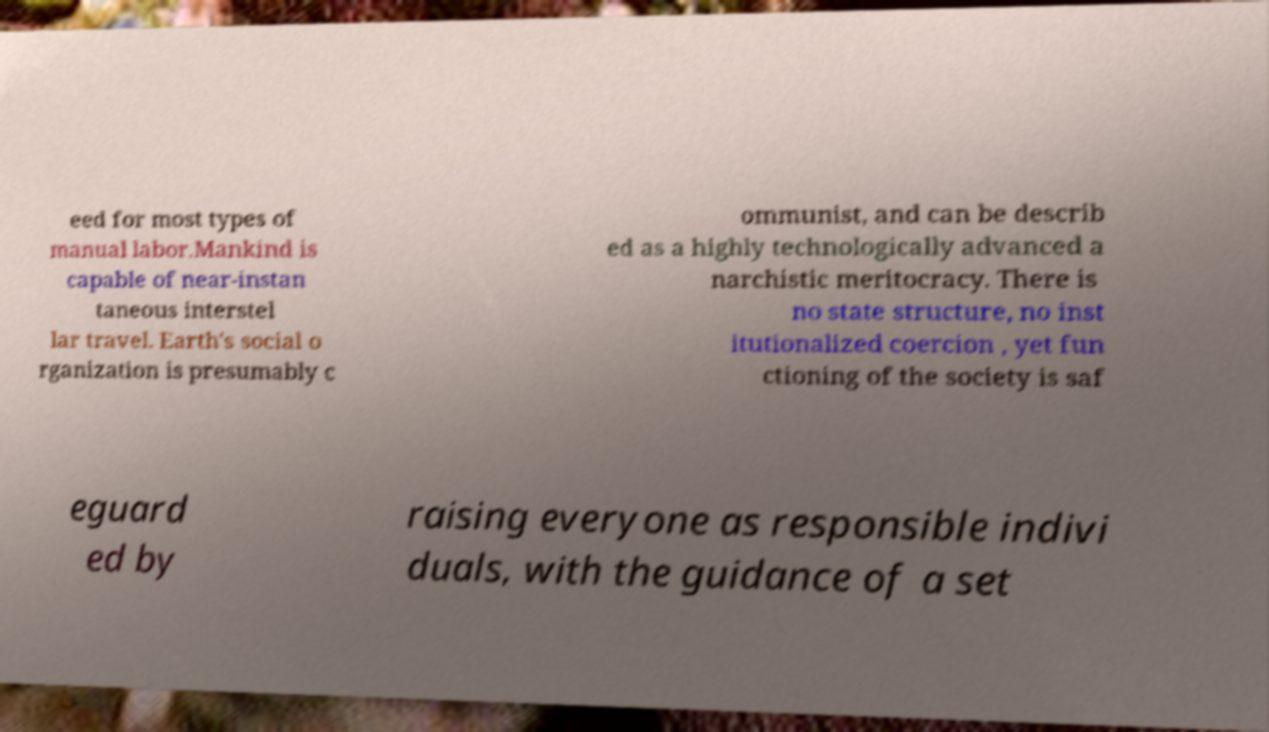Could you assist in decoding the text presented in this image and type it out clearly? eed for most types of manual labor.Mankind is capable of near-instan taneous interstel lar travel. Earth's social o rganization is presumably c ommunist, and can be describ ed as a highly technologically advanced a narchistic meritocracy. There is no state structure, no inst itutionalized coercion , yet fun ctioning of the society is saf eguard ed by raising everyone as responsible indivi duals, with the guidance of a set 